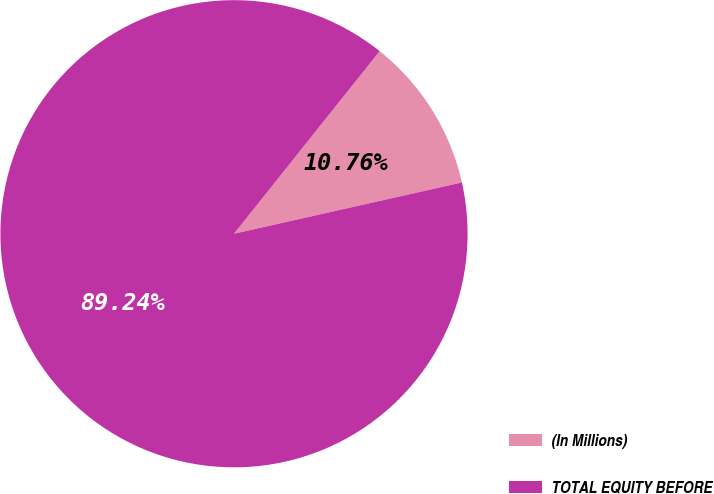Convert chart to OTSL. <chart><loc_0><loc_0><loc_500><loc_500><pie_chart><fcel>(In Millions)<fcel>TOTAL EQUITY BEFORE<nl><fcel>10.76%<fcel>89.24%<nl></chart> 